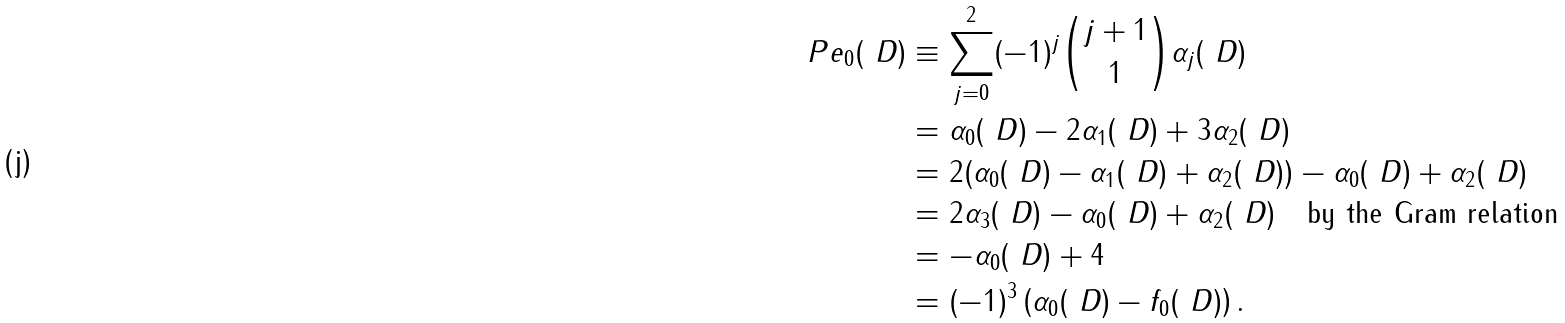<formula> <loc_0><loc_0><loc_500><loc_500>P e _ { 0 } ( \ D ) & \equiv \sum _ { j = 0 } ^ { 2 } ( - 1 ) ^ { j } { j + 1 \choose 1 } \alpha _ { j } ( \ D ) \\ & = \alpha _ { 0 } ( \ D ) - 2 \alpha _ { 1 } ( \ D ) + 3 \alpha _ { 2 } ( \ D ) \\ & = 2 ( \alpha _ { 0 } ( \ D ) - \alpha _ { 1 } ( \ D ) + \alpha _ { 2 } ( \ D ) ) - \alpha _ { 0 } ( \ D ) + \alpha _ { 2 } ( \ D ) \\ & = 2 \alpha _ { 3 } ( \ D ) - \alpha _ { 0 } ( \ D ) + \alpha _ { 2 } ( \ D ) \quad \text {by the Gram relation} \\ & = - \alpha _ { 0 } ( \ D ) + 4 \\ & = ( - 1 ) ^ { 3 } \left ( \alpha _ { 0 } ( \ D ) - f _ { 0 } ( \ D ) \right ) .</formula> 